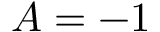Convert formula to latex. <formula><loc_0><loc_0><loc_500><loc_500>A = - 1</formula> 